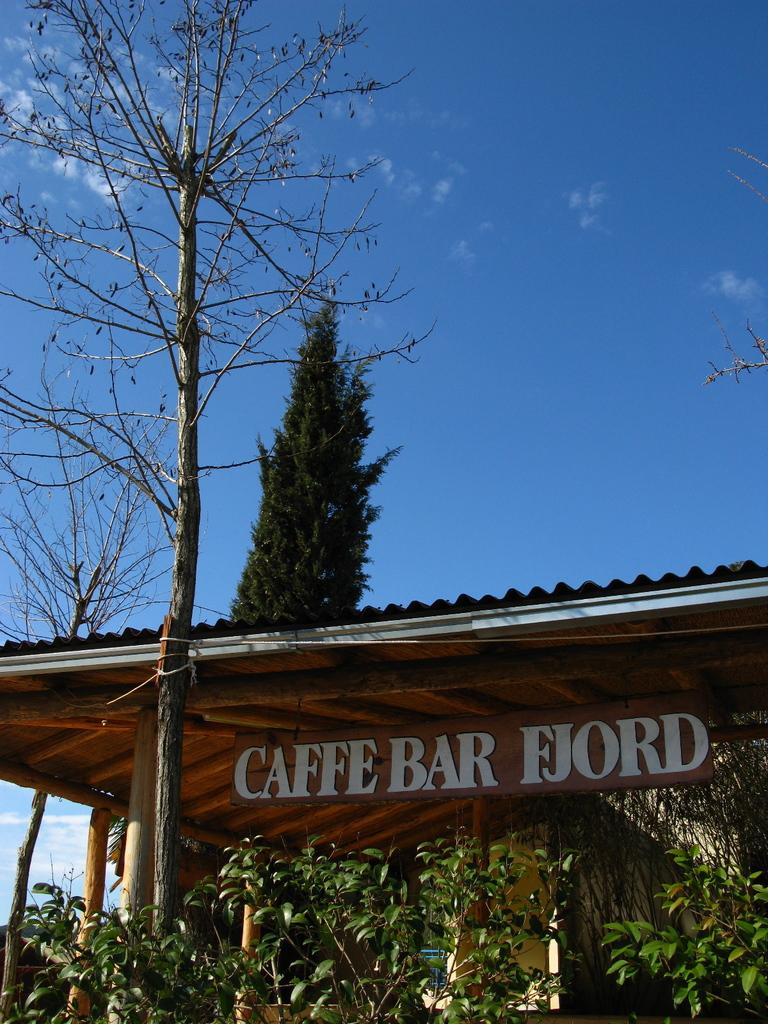What type of establishment is shown in the image? There is a coffee shop in the image. What can be seen inside the coffee shop? Plants are visible inside the coffee shop. What is visible in the background of the image? There is a tree and the sky visible in the background of the image. What is the condition of the sky in the image? The sky has clouds in the image. What type of afterthought is expressed by the lawyer in the image? There is no lawyer or afterthought present in the image; it features a coffee shop with plants and a tree in the background. What is the belief system of the person standing near the tree in the image? There is no person standing near the tree in the image, and therefore no belief system can be determined. 